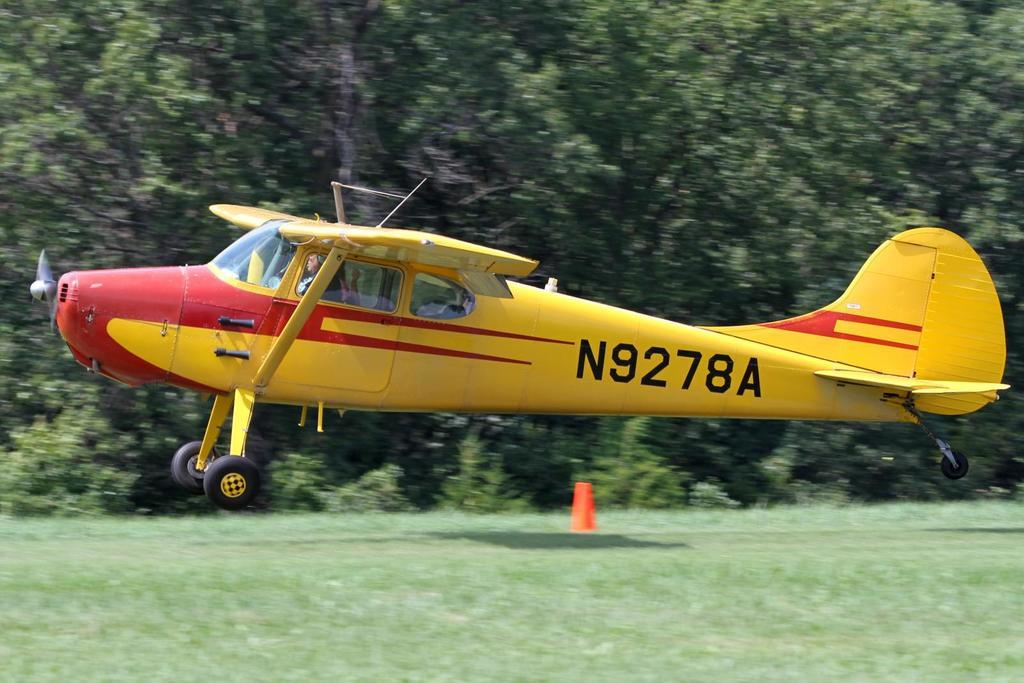What color is the airplane in the picture? The airplane in the picture is yellow. What can be seen in the background of the picture? There are trees in the background of the picture. How many square feet of space does the airplane occupy in the picture? The provided facts do not give information about the size of the airplane or the dimensions of the image, so it is not possible to determine the square footage it occupies. 